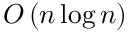Convert formula to latex. <formula><loc_0><loc_0><loc_500><loc_500>O \left ( n \log n \right )</formula> 